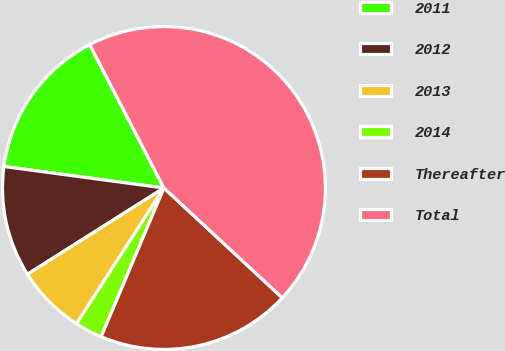Convert chart. <chart><loc_0><loc_0><loc_500><loc_500><pie_chart><fcel>2011<fcel>2012<fcel>2013<fcel>2014<fcel>Thereafter<fcel>Total<nl><fcel>15.27%<fcel>11.1%<fcel>6.92%<fcel>2.75%<fcel>19.45%<fcel>44.51%<nl></chart> 